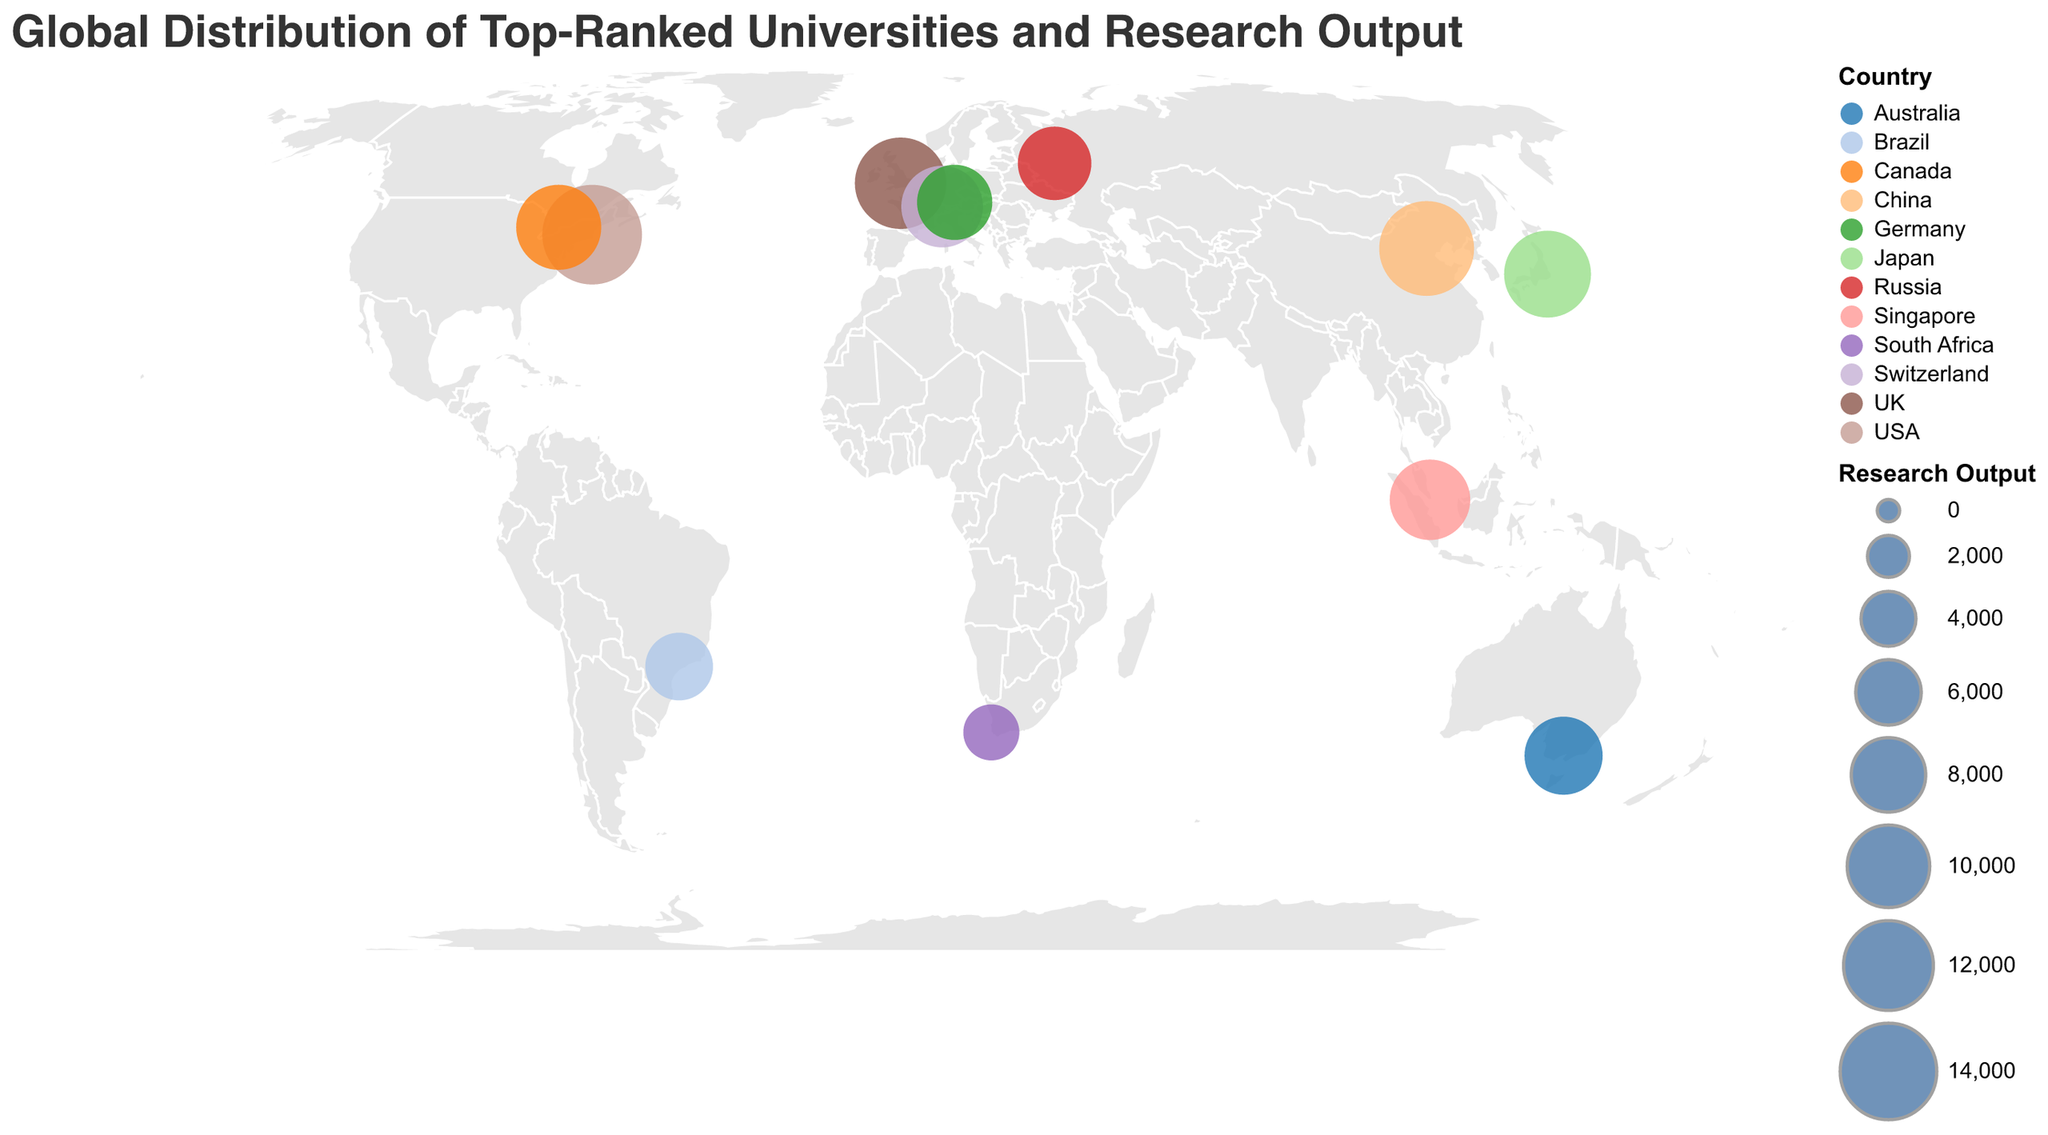Which university has the highest research output? The university with the largest circle represents the highest research output. Harvard University has the largest circle, indicating it has the highest research output.
Answer: Harvard University What is the total research output of universities in the USA and UK combined? Identify the research output of universities in the USA and UK: Harvard University (15000) and University of Oxford (12500). Summing them gives 15000 + 12500 = 27500.
Answer: 27500 Which country is represented by the circle located around latitude 35.71 and longitude 139.76? The circle's location corresponds to the coordinates of the University of Tokyo in Japan.
Answer: Japan How many universities are represented in the Southern Hemisphere? Check the latitude coordinates to see which universities are in the Southern Hemisphere (negative latitude). Universities are in Australia (University of Melbourne), South Africa (University of Cape Town), and Brazil (University of São Paulo). Total is 3.
Answer: 3 Which university in Asia has the highest research output? Compare the research outputs of universities in Asia (National University of Singapore, Tsinghua University, and University of Tokyo), where Tsinghua University has the highest research output of 13500.
Answer: Tsinghua University Which two universities are closest in research output, and what are their values? Compare the research outputs and find the closest pair. University of Melbourne (8900) and National University of Singapore (9500) have a difference of 600, which is the smallest compared to other pairs.
Answer: University of Melbourne and National University of Singapore, 8900 and 9500 How does the research output of the University of São Paulo compare to the National University of Singapore? The University of São Paulo has a research output of 6500, and the National University of Singapore has a research output of 9500. 9500 - 6500 = 3000, so São Paulo has 3000 less.
Answer: 3000 less Identify all continents represented by these universities. Check the countries of all universities and identify their continents: North America (USA, Canada), Europe (UK, Switzerland, Germany, Russia), Asia (China, Japan, Singapore), Australia (University of Melbourne), Africa (South Africa), South America (Brazil).
Answer: North America, Europe, Asia, Australia, Africa, South America Which university is represented by the circle at the highest longitude? The circle with the highest longitude (144.9612) corresponds to the University of Melbourne in Australia.
Answer: University of Melbourne What is the smallest research output shown, and which university does it belong to? Identify the smallest circle or check the research output values. The smallest value is 4200, belonging to the University of Cape Town.
Answer: University of Cape Town, 4200 